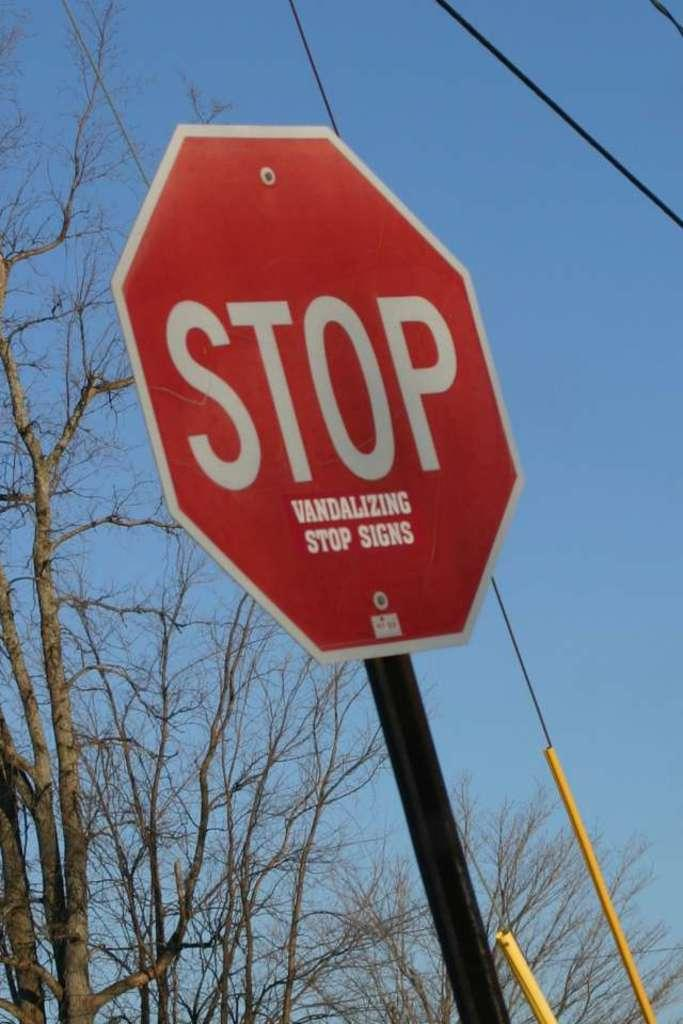Provide a one-sentence caption for the provided image. Octagon sign that reads STOP VANDALIZING STOP SIGNS. 